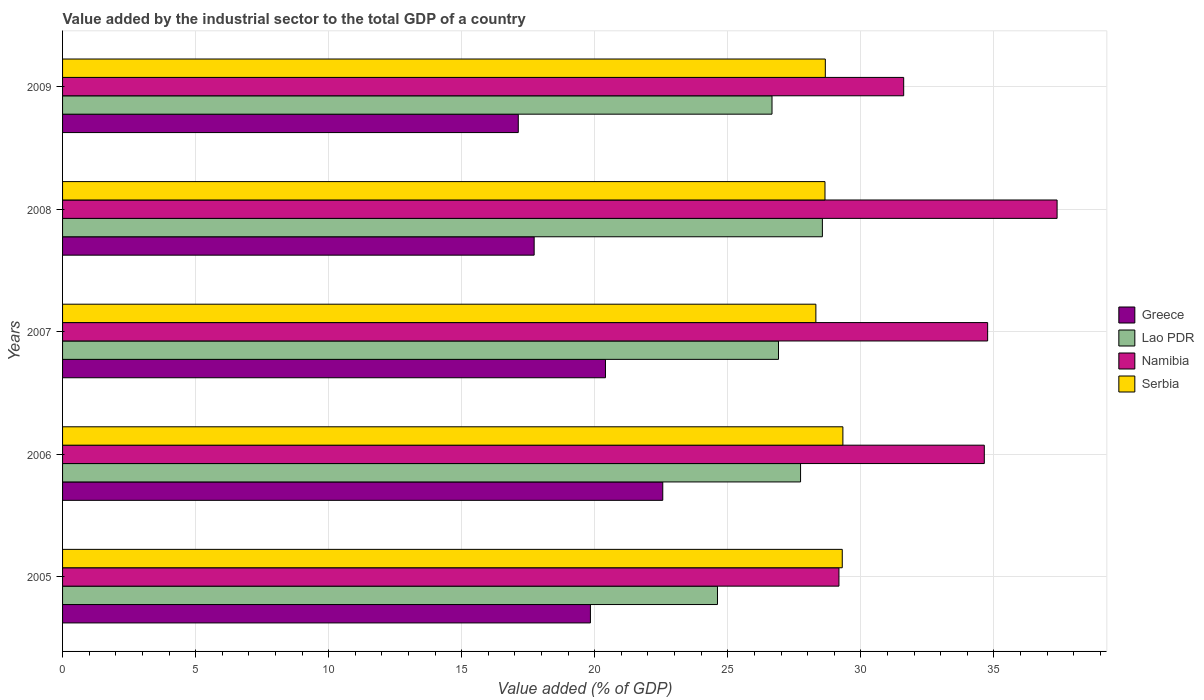How many different coloured bars are there?
Provide a short and direct response. 4. Are the number of bars on each tick of the Y-axis equal?
Keep it short and to the point. Yes. What is the value added by the industrial sector to the total GDP in Serbia in 2009?
Your answer should be compact. 28.67. Across all years, what is the maximum value added by the industrial sector to the total GDP in Greece?
Keep it short and to the point. 22.56. Across all years, what is the minimum value added by the industrial sector to the total GDP in Lao PDR?
Make the answer very short. 24.61. In which year was the value added by the industrial sector to the total GDP in Lao PDR minimum?
Make the answer very short. 2005. What is the total value added by the industrial sector to the total GDP in Lao PDR in the graph?
Your response must be concise. 134.47. What is the difference between the value added by the industrial sector to the total GDP in Namibia in 2006 and that in 2008?
Give a very brief answer. -2.74. What is the difference between the value added by the industrial sector to the total GDP in Serbia in 2005 and the value added by the industrial sector to the total GDP in Greece in 2009?
Your answer should be compact. 12.18. What is the average value added by the industrial sector to the total GDP in Greece per year?
Your response must be concise. 19.53. In the year 2005, what is the difference between the value added by the industrial sector to the total GDP in Greece and value added by the industrial sector to the total GDP in Namibia?
Your response must be concise. -9.34. What is the ratio of the value added by the industrial sector to the total GDP in Serbia in 2005 to that in 2009?
Make the answer very short. 1.02. Is the value added by the industrial sector to the total GDP in Serbia in 2006 less than that in 2007?
Your response must be concise. No. What is the difference between the highest and the second highest value added by the industrial sector to the total GDP in Namibia?
Your answer should be very brief. 2.61. What is the difference between the highest and the lowest value added by the industrial sector to the total GDP in Lao PDR?
Provide a succinct answer. 3.94. In how many years, is the value added by the industrial sector to the total GDP in Serbia greater than the average value added by the industrial sector to the total GDP in Serbia taken over all years?
Your answer should be compact. 2. Is the sum of the value added by the industrial sector to the total GDP in Greece in 2005 and 2006 greater than the maximum value added by the industrial sector to the total GDP in Serbia across all years?
Your answer should be very brief. Yes. Is it the case that in every year, the sum of the value added by the industrial sector to the total GDP in Greece and value added by the industrial sector to the total GDP in Namibia is greater than the sum of value added by the industrial sector to the total GDP in Lao PDR and value added by the industrial sector to the total GDP in Serbia?
Make the answer very short. No. What does the 4th bar from the top in 2005 represents?
Keep it short and to the point. Greece. What does the 3rd bar from the bottom in 2009 represents?
Your answer should be very brief. Namibia. Is it the case that in every year, the sum of the value added by the industrial sector to the total GDP in Namibia and value added by the industrial sector to the total GDP in Greece is greater than the value added by the industrial sector to the total GDP in Serbia?
Give a very brief answer. Yes. How many bars are there?
Your answer should be very brief. 20. How many years are there in the graph?
Provide a succinct answer. 5. Does the graph contain any zero values?
Ensure brevity in your answer.  No. How many legend labels are there?
Make the answer very short. 4. How are the legend labels stacked?
Give a very brief answer. Vertical. What is the title of the graph?
Offer a terse response. Value added by the industrial sector to the total GDP of a country. What is the label or title of the X-axis?
Offer a very short reply. Value added (% of GDP). What is the Value added (% of GDP) of Greece in 2005?
Make the answer very short. 19.84. What is the Value added (% of GDP) in Lao PDR in 2005?
Offer a very short reply. 24.61. What is the Value added (% of GDP) in Namibia in 2005?
Give a very brief answer. 29.18. What is the Value added (% of GDP) in Serbia in 2005?
Make the answer very short. 29.3. What is the Value added (% of GDP) in Greece in 2006?
Provide a short and direct response. 22.56. What is the Value added (% of GDP) of Lao PDR in 2006?
Make the answer very short. 27.73. What is the Value added (% of GDP) of Namibia in 2006?
Offer a terse response. 34.64. What is the Value added (% of GDP) in Serbia in 2006?
Your response must be concise. 29.33. What is the Value added (% of GDP) of Greece in 2007?
Make the answer very short. 20.4. What is the Value added (% of GDP) of Lao PDR in 2007?
Ensure brevity in your answer.  26.91. What is the Value added (% of GDP) of Namibia in 2007?
Provide a short and direct response. 34.77. What is the Value added (% of GDP) in Serbia in 2007?
Ensure brevity in your answer.  28.31. What is the Value added (% of GDP) in Greece in 2008?
Ensure brevity in your answer.  17.72. What is the Value added (% of GDP) in Lao PDR in 2008?
Offer a very short reply. 28.56. What is the Value added (% of GDP) in Namibia in 2008?
Offer a very short reply. 37.38. What is the Value added (% of GDP) in Serbia in 2008?
Ensure brevity in your answer.  28.65. What is the Value added (% of GDP) of Greece in 2009?
Offer a very short reply. 17.13. What is the Value added (% of GDP) of Lao PDR in 2009?
Make the answer very short. 26.66. What is the Value added (% of GDP) of Namibia in 2009?
Provide a short and direct response. 31.61. What is the Value added (% of GDP) in Serbia in 2009?
Keep it short and to the point. 28.67. Across all years, what is the maximum Value added (% of GDP) in Greece?
Ensure brevity in your answer.  22.56. Across all years, what is the maximum Value added (% of GDP) in Lao PDR?
Make the answer very short. 28.56. Across all years, what is the maximum Value added (% of GDP) in Namibia?
Give a very brief answer. 37.38. Across all years, what is the maximum Value added (% of GDP) in Serbia?
Give a very brief answer. 29.33. Across all years, what is the minimum Value added (% of GDP) of Greece?
Your response must be concise. 17.13. Across all years, what is the minimum Value added (% of GDP) in Lao PDR?
Your response must be concise. 24.61. Across all years, what is the minimum Value added (% of GDP) in Namibia?
Your answer should be very brief. 29.18. Across all years, what is the minimum Value added (% of GDP) in Serbia?
Ensure brevity in your answer.  28.31. What is the total Value added (% of GDP) of Greece in the graph?
Make the answer very short. 97.65. What is the total Value added (% of GDP) in Lao PDR in the graph?
Provide a succinct answer. 134.47. What is the total Value added (% of GDP) of Namibia in the graph?
Offer a terse response. 167.57. What is the total Value added (% of GDP) of Serbia in the graph?
Make the answer very short. 144.26. What is the difference between the Value added (% of GDP) of Greece in 2005 and that in 2006?
Ensure brevity in your answer.  -2.72. What is the difference between the Value added (% of GDP) in Lao PDR in 2005 and that in 2006?
Offer a very short reply. -3.12. What is the difference between the Value added (% of GDP) in Namibia in 2005 and that in 2006?
Keep it short and to the point. -5.46. What is the difference between the Value added (% of GDP) in Serbia in 2005 and that in 2006?
Provide a succinct answer. -0.02. What is the difference between the Value added (% of GDP) in Greece in 2005 and that in 2007?
Keep it short and to the point. -0.57. What is the difference between the Value added (% of GDP) of Lao PDR in 2005 and that in 2007?
Your response must be concise. -2.29. What is the difference between the Value added (% of GDP) of Namibia in 2005 and that in 2007?
Your response must be concise. -5.59. What is the difference between the Value added (% of GDP) of Serbia in 2005 and that in 2007?
Your answer should be compact. 0.99. What is the difference between the Value added (% of GDP) in Greece in 2005 and that in 2008?
Your answer should be very brief. 2.11. What is the difference between the Value added (% of GDP) in Lao PDR in 2005 and that in 2008?
Give a very brief answer. -3.94. What is the difference between the Value added (% of GDP) in Namibia in 2005 and that in 2008?
Keep it short and to the point. -8.2. What is the difference between the Value added (% of GDP) of Serbia in 2005 and that in 2008?
Offer a terse response. 0.65. What is the difference between the Value added (% of GDP) in Greece in 2005 and that in 2009?
Your answer should be very brief. 2.71. What is the difference between the Value added (% of GDP) in Lao PDR in 2005 and that in 2009?
Provide a succinct answer. -2.05. What is the difference between the Value added (% of GDP) of Namibia in 2005 and that in 2009?
Provide a short and direct response. -2.43. What is the difference between the Value added (% of GDP) in Serbia in 2005 and that in 2009?
Your answer should be compact. 0.64. What is the difference between the Value added (% of GDP) of Greece in 2006 and that in 2007?
Provide a short and direct response. 2.15. What is the difference between the Value added (% of GDP) in Lao PDR in 2006 and that in 2007?
Ensure brevity in your answer.  0.83. What is the difference between the Value added (% of GDP) in Namibia in 2006 and that in 2007?
Ensure brevity in your answer.  -0.13. What is the difference between the Value added (% of GDP) of Serbia in 2006 and that in 2007?
Offer a very short reply. 1.02. What is the difference between the Value added (% of GDP) in Greece in 2006 and that in 2008?
Your response must be concise. 4.83. What is the difference between the Value added (% of GDP) in Lao PDR in 2006 and that in 2008?
Offer a very short reply. -0.82. What is the difference between the Value added (% of GDP) of Namibia in 2006 and that in 2008?
Provide a short and direct response. -2.74. What is the difference between the Value added (% of GDP) of Serbia in 2006 and that in 2008?
Your response must be concise. 0.67. What is the difference between the Value added (% of GDP) in Greece in 2006 and that in 2009?
Provide a succinct answer. 5.43. What is the difference between the Value added (% of GDP) of Lao PDR in 2006 and that in 2009?
Make the answer very short. 1.07. What is the difference between the Value added (% of GDP) in Namibia in 2006 and that in 2009?
Make the answer very short. 3.03. What is the difference between the Value added (% of GDP) of Serbia in 2006 and that in 2009?
Keep it short and to the point. 0.66. What is the difference between the Value added (% of GDP) in Greece in 2007 and that in 2008?
Your response must be concise. 2.68. What is the difference between the Value added (% of GDP) of Lao PDR in 2007 and that in 2008?
Your answer should be very brief. -1.65. What is the difference between the Value added (% of GDP) of Namibia in 2007 and that in 2008?
Ensure brevity in your answer.  -2.61. What is the difference between the Value added (% of GDP) of Serbia in 2007 and that in 2008?
Give a very brief answer. -0.34. What is the difference between the Value added (% of GDP) of Greece in 2007 and that in 2009?
Provide a succinct answer. 3.28. What is the difference between the Value added (% of GDP) in Lao PDR in 2007 and that in 2009?
Your answer should be very brief. 0.24. What is the difference between the Value added (% of GDP) of Namibia in 2007 and that in 2009?
Make the answer very short. 3.15. What is the difference between the Value added (% of GDP) in Serbia in 2007 and that in 2009?
Your answer should be very brief. -0.36. What is the difference between the Value added (% of GDP) of Greece in 2008 and that in 2009?
Offer a very short reply. 0.6. What is the difference between the Value added (% of GDP) in Lao PDR in 2008 and that in 2009?
Provide a short and direct response. 1.89. What is the difference between the Value added (% of GDP) in Namibia in 2008 and that in 2009?
Provide a succinct answer. 5.77. What is the difference between the Value added (% of GDP) in Serbia in 2008 and that in 2009?
Provide a succinct answer. -0.01. What is the difference between the Value added (% of GDP) in Greece in 2005 and the Value added (% of GDP) in Lao PDR in 2006?
Provide a succinct answer. -7.9. What is the difference between the Value added (% of GDP) in Greece in 2005 and the Value added (% of GDP) in Namibia in 2006?
Provide a short and direct response. -14.8. What is the difference between the Value added (% of GDP) of Greece in 2005 and the Value added (% of GDP) of Serbia in 2006?
Your answer should be very brief. -9.49. What is the difference between the Value added (% of GDP) in Lao PDR in 2005 and the Value added (% of GDP) in Namibia in 2006?
Ensure brevity in your answer.  -10.03. What is the difference between the Value added (% of GDP) of Lao PDR in 2005 and the Value added (% of GDP) of Serbia in 2006?
Ensure brevity in your answer.  -4.71. What is the difference between the Value added (% of GDP) of Namibia in 2005 and the Value added (% of GDP) of Serbia in 2006?
Your response must be concise. -0.15. What is the difference between the Value added (% of GDP) in Greece in 2005 and the Value added (% of GDP) in Lao PDR in 2007?
Provide a short and direct response. -7.07. What is the difference between the Value added (% of GDP) in Greece in 2005 and the Value added (% of GDP) in Namibia in 2007?
Provide a short and direct response. -14.93. What is the difference between the Value added (% of GDP) of Greece in 2005 and the Value added (% of GDP) of Serbia in 2007?
Offer a terse response. -8.47. What is the difference between the Value added (% of GDP) in Lao PDR in 2005 and the Value added (% of GDP) in Namibia in 2007?
Provide a succinct answer. -10.15. What is the difference between the Value added (% of GDP) of Lao PDR in 2005 and the Value added (% of GDP) of Serbia in 2007?
Your answer should be very brief. -3.7. What is the difference between the Value added (% of GDP) in Namibia in 2005 and the Value added (% of GDP) in Serbia in 2007?
Provide a short and direct response. 0.87. What is the difference between the Value added (% of GDP) of Greece in 2005 and the Value added (% of GDP) of Lao PDR in 2008?
Your answer should be very brief. -8.72. What is the difference between the Value added (% of GDP) in Greece in 2005 and the Value added (% of GDP) in Namibia in 2008?
Your response must be concise. -17.54. What is the difference between the Value added (% of GDP) of Greece in 2005 and the Value added (% of GDP) of Serbia in 2008?
Ensure brevity in your answer.  -8.81. What is the difference between the Value added (% of GDP) of Lao PDR in 2005 and the Value added (% of GDP) of Namibia in 2008?
Keep it short and to the point. -12.76. What is the difference between the Value added (% of GDP) in Lao PDR in 2005 and the Value added (% of GDP) in Serbia in 2008?
Offer a very short reply. -4.04. What is the difference between the Value added (% of GDP) in Namibia in 2005 and the Value added (% of GDP) in Serbia in 2008?
Provide a succinct answer. 0.53. What is the difference between the Value added (% of GDP) in Greece in 2005 and the Value added (% of GDP) in Lao PDR in 2009?
Give a very brief answer. -6.82. What is the difference between the Value added (% of GDP) of Greece in 2005 and the Value added (% of GDP) of Namibia in 2009?
Offer a very short reply. -11.77. What is the difference between the Value added (% of GDP) of Greece in 2005 and the Value added (% of GDP) of Serbia in 2009?
Provide a short and direct response. -8.83. What is the difference between the Value added (% of GDP) of Lao PDR in 2005 and the Value added (% of GDP) of Namibia in 2009?
Your answer should be very brief. -7. What is the difference between the Value added (% of GDP) in Lao PDR in 2005 and the Value added (% of GDP) in Serbia in 2009?
Keep it short and to the point. -4.05. What is the difference between the Value added (% of GDP) in Namibia in 2005 and the Value added (% of GDP) in Serbia in 2009?
Your answer should be compact. 0.51. What is the difference between the Value added (% of GDP) of Greece in 2006 and the Value added (% of GDP) of Lao PDR in 2007?
Your answer should be compact. -4.35. What is the difference between the Value added (% of GDP) in Greece in 2006 and the Value added (% of GDP) in Namibia in 2007?
Provide a short and direct response. -12.21. What is the difference between the Value added (% of GDP) of Greece in 2006 and the Value added (% of GDP) of Serbia in 2007?
Keep it short and to the point. -5.75. What is the difference between the Value added (% of GDP) in Lao PDR in 2006 and the Value added (% of GDP) in Namibia in 2007?
Your answer should be compact. -7.03. What is the difference between the Value added (% of GDP) of Lao PDR in 2006 and the Value added (% of GDP) of Serbia in 2007?
Your answer should be compact. -0.58. What is the difference between the Value added (% of GDP) of Namibia in 2006 and the Value added (% of GDP) of Serbia in 2007?
Give a very brief answer. 6.33. What is the difference between the Value added (% of GDP) of Greece in 2006 and the Value added (% of GDP) of Lao PDR in 2008?
Your answer should be compact. -6. What is the difference between the Value added (% of GDP) in Greece in 2006 and the Value added (% of GDP) in Namibia in 2008?
Your response must be concise. -14.82. What is the difference between the Value added (% of GDP) in Greece in 2006 and the Value added (% of GDP) in Serbia in 2008?
Your answer should be compact. -6.1. What is the difference between the Value added (% of GDP) of Lao PDR in 2006 and the Value added (% of GDP) of Namibia in 2008?
Ensure brevity in your answer.  -9.64. What is the difference between the Value added (% of GDP) of Lao PDR in 2006 and the Value added (% of GDP) of Serbia in 2008?
Keep it short and to the point. -0.92. What is the difference between the Value added (% of GDP) in Namibia in 2006 and the Value added (% of GDP) in Serbia in 2008?
Make the answer very short. 5.99. What is the difference between the Value added (% of GDP) in Greece in 2006 and the Value added (% of GDP) in Lao PDR in 2009?
Keep it short and to the point. -4.11. What is the difference between the Value added (% of GDP) in Greece in 2006 and the Value added (% of GDP) in Namibia in 2009?
Provide a succinct answer. -9.05. What is the difference between the Value added (% of GDP) in Greece in 2006 and the Value added (% of GDP) in Serbia in 2009?
Offer a very short reply. -6.11. What is the difference between the Value added (% of GDP) in Lao PDR in 2006 and the Value added (% of GDP) in Namibia in 2009?
Ensure brevity in your answer.  -3.88. What is the difference between the Value added (% of GDP) of Lao PDR in 2006 and the Value added (% of GDP) of Serbia in 2009?
Your response must be concise. -0.93. What is the difference between the Value added (% of GDP) of Namibia in 2006 and the Value added (% of GDP) of Serbia in 2009?
Your answer should be compact. 5.97. What is the difference between the Value added (% of GDP) of Greece in 2007 and the Value added (% of GDP) of Lao PDR in 2008?
Provide a succinct answer. -8.15. What is the difference between the Value added (% of GDP) of Greece in 2007 and the Value added (% of GDP) of Namibia in 2008?
Give a very brief answer. -16.97. What is the difference between the Value added (% of GDP) in Greece in 2007 and the Value added (% of GDP) in Serbia in 2008?
Provide a succinct answer. -8.25. What is the difference between the Value added (% of GDP) in Lao PDR in 2007 and the Value added (% of GDP) in Namibia in 2008?
Provide a short and direct response. -10.47. What is the difference between the Value added (% of GDP) in Lao PDR in 2007 and the Value added (% of GDP) in Serbia in 2008?
Ensure brevity in your answer.  -1.75. What is the difference between the Value added (% of GDP) of Namibia in 2007 and the Value added (% of GDP) of Serbia in 2008?
Your answer should be compact. 6.11. What is the difference between the Value added (% of GDP) of Greece in 2007 and the Value added (% of GDP) of Lao PDR in 2009?
Make the answer very short. -6.26. What is the difference between the Value added (% of GDP) in Greece in 2007 and the Value added (% of GDP) in Namibia in 2009?
Ensure brevity in your answer.  -11.21. What is the difference between the Value added (% of GDP) in Greece in 2007 and the Value added (% of GDP) in Serbia in 2009?
Offer a terse response. -8.26. What is the difference between the Value added (% of GDP) in Lao PDR in 2007 and the Value added (% of GDP) in Namibia in 2009?
Offer a very short reply. -4.71. What is the difference between the Value added (% of GDP) of Lao PDR in 2007 and the Value added (% of GDP) of Serbia in 2009?
Keep it short and to the point. -1.76. What is the difference between the Value added (% of GDP) in Namibia in 2007 and the Value added (% of GDP) in Serbia in 2009?
Your answer should be compact. 6.1. What is the difference between the Value added (% of GDP) in Greece in 2008 and the Value added (% of GDP) in Lao PDR in 2009?
Provide a succinct answer. -8.94. What is the difference between the Value added (% of GDP) in Greece in 2008 and the Value added (% of GDP) in Namibia in 2009?
Your response must be concise. -13.89. What is the difference between the Value added (% of GDP) in Greece in 2008 and the Value added (% of GDP) in Serbia in 2009?
Your response must be concise. -10.94. What is the difference between the Value added (% of GDP) of Lao PDR in 2008 and the Value added (% of GDP) of Namibia in 2009?
Ensure brevity in your answer.  -3.06. What is the difference between the Value added (% of GDP) of Lao PDR in 2008 and the Value added (% of GDP) of Serbia in 2009?
Make the answer very short. -0.11. What is the difference between the Value added (% of GDP) of Namibia in 2008 and the Value added (% of GDP) of Serbia in 2009?
Make the answer very short. 8.71. What is the average Value added (% of GDP) in Greece per year?
Offer a terse response. 19.53. What is the average Value added (% of GDP) in Lao PDR per year?
Keep it short and to the point. 26.89. What is the average Value added (% of GDP) in Namibia per year?
Your answer should be compact. 33.51. What is the average Value added (% of GDP) in Serbia per year?
Offer a terse response. 28.85. In the year 2005, what is the difference between the Value added (% of GDP) in Greece and Value added (% of GDP) in Lao PDR?
Ensure brevity in your answer.  -4.77. In the year 2005, what is the difference between the Value added (% of GDP) in Greece and Value added (% of GDP) in Namibia?
Offer a terse response. -9.34. In the year 2005, what is the difference between the Value added (% of GDP) of Greece and Value added (% of GDP) of Serbia?
Ensure brevity in your answer.  -9.46. In the year 2005, what is the difference between the Value added (% of GDP) in Lao PDR and Value added (% of GDP) in Namibia?
Provide a succinct answer. -4.57. In the year 2005, what is the difference between the Value added (% of GDP) of Lao PDR and Value added (% of GDP) of Serbia?
Your response must be concise. -4.69. In the year 2005, what is the difference between the Value added (% of GDP) of Namibia and Value added (% of GDP) of Serbia?
Make the answer very short. -0.12. In the year 2006, what is the difference between the Value added (% of GDP) in Greece and Value added (% of GDP) in Lao PDR?
Offer a very short reply. -5.18. In the year 2006, what is the difference between the Value added (% of GDP) of Greece and Value added (% of GDP) of Namibia?
Offer a terse response. -12.08. In the year 2006, what is the difference between the Value added (% of GDP) in Greece and Value added (% of GDP) in Serbia?
Your response must be concise. -6.77. In the year 2006, what is the difference between the Value added (% of GDP) of Lao PDR and Value added (% of GDP) of Namibia?
Make the answer very short. -6.91. In the year 2006, what is the difference between the Value added (% of GDP) of Lao PDR and Value added (% of GDP) of Serbia?
Provide a short and direct response. -1.59. In the year 2006, what is the difference between the Value added (% of GDP) in Namibia and Value added (% of GDP) in Serbia?
Your answer should be compact. 5.31. In the year 2007, what is the difference between the Value added (% of GDP) in Greece and Value added (% of GDP) in Lao PDR?
Provide a succinct answer. -6.5. In the year 2007, what is the difference between the Value added (% of GDP) of Greece and Value added (% of GDP) of Namibia?
Make the answer very short. -14.36. In the year 2007, what is the difference between the Value added (% of GDP) of Greece and Value added (% of GDP) of Serbia?
Your answer should be very brief. -7.91. In the year 2007, what is the difference between the Value added (% of GDP) of Lao PDR and Value added (% of GDP) of Namibia?
Provide a succinct answer. -7.86. In the year 2007, what is the difference between the Value added (% of GDP) of Lao PDR and Value added (% of GDP) of Serbia?
Provide a succinct answer. -1.4. In the year 2007, what is the difference between the Value added (% of GDP) in Namibia and Value added (% of GDP) in Serbia?
Keep it short and to the point. 6.46. In the year 2008, what is the difference between the Value added (% of GDP) of Greece and Value added (% of GDP) of Lao PDR?
Your answer should be very brief. -10.83. In the year 2008, what is the difference between the Value added (% of GDP) of Greece and Value added (% of GDP) of Namibia?
Your answer should be compact. -19.65. In the year 2008, what is the difference between the Value added (% of GDP) of Greece and Value added (% of GDP) of Serbia?
Offer a very short reply. -10.93. In the year 2008, what is the difference between the Value added (% of GDP) of Lao PDR and Value added (% of GDP) of Namibia?
Ensure brevity in your answer.  -8.82. In the year 2008, what is the difference between the Value added (% of GDP) of Lao PDR and Value added (% of GDP) of Serbia?
Keep it short and to the point. -0.1. In the year 2008, what is the difference between the Value added (% of GDP) of Namibia and Value added (% of GDP) of Serbia?
Give a very brief answer. 8.72. In the year 2009, what is the difference between the Value added (% of GDP) of Greece and Value added (% of GDP) of Lao PDR?
Keep it short and to the point. -9.54. In the year 2009, what is the difference between the Value added (% of GDP) in Greece and Value added (% of GDP) in Namibia?
Your answer should be very brief. -14.48. In the year 2009, what is the difference between the Value added (% of GDP) in Greece and Value added (% of GDP) in Serbia?
Your answer should be very brief. -11.54. In the year 2009, what is the difference between the Value added (% of GDP) in Lao PDR and Value added (% of GDP) in Namibia?
Make the answer very short. -4.95. In the year 2009, what is the difference between the Value added (% of GDP) of Lao PDR and Value added (% of GDP) of Serbia?
Provide a succinct answer. -2. In the year 2009, what is the difference between the Value added (% of GDP) in Namibia and Value added (% of GDP) in Serbia?
Give a very brief answer. 2.95. What is the ratio of the Value added (% of GDP) in Greece in 2005 to that in 2006?
Provide a short and direct response. 0.88. What is the ratio of the Value added (% of GDP) of Lao PDR in 2005 to that in 2006?
Offer a very short reply. 0.89. What is the ratio of the Value added (% of GDP) in Namibia in 2005 to that in 2006?
Your response must be concise. 0.84. What is the ratio of the Value added (% of GDP) of Serbia in 2005 to that in 2006?
Your response must be concise. 1. What is the ratio of the Value added (% of GDP) of Greece in 2005 to that in 2007?
Keep it short and to the point. 0.97. What is the ratio of the Value added (% of GDP) of Lao PDR in 2005 to that in 2007?
Your answer should be very brief. 0.91. What is the ratio of the Value added (% of GDP) in Namibia in 2005 to that in 2007?
Keep it short and to the point. 0.84. What is the ratio of the Value added (% of GDP) of Serbia in 2005 to that in 2007?
Make the answer very short. 1.03. What is the ratio of the Value added (% of GDP) in Greece in 2005 to that in 2008?
Your response must be concise. 1.12. What is the ratio of the Value added (% of GDP) of Lao PDR in 2005 to that in 2008?
Provide a succinct answer. 0.86. What is the ratio of the Value added (% of GDP) of Namibia in 2005 to that in 2008?
Keep it short and to the point. 0.78. What is the ratio of the Value added (% of GDP) of Serbia in 2005 to that in 2008?
Your answer should be very brief. 1.02. What is the ratio of the Value added (% of GDP) in Greece in 2005 to that in 2009?
Provide a short and direct response. 1.16. What is the ratio of the Value added (% of GDP) in Lao PDR in 2005 to that in 2009?
Your response must be concise. 0.92. What is the ratio of the Value added (% of GDP) in Namibia in 2005 to that in 2009?
Your answer should be compact. 0.92. What is the ratio of the Value added (% of GDP) of Serbia in 2005 to that in 2009?
Provide a succinct answer. 1.02. What is the ratio of the Value added (% of GDP) of Greece in 2006 to that in 2007?
Provide a succinct answer. 1.11. What is the ratio of the Value added (% of GDP) in Lao PDR in 2006 to that in 2007?
Provide a succinct answer. 1.03. What is the ratio of the Value added (% of GDP) of Serbia in 2006 to that in 2007?
Provide a succinct answer. 1.04. What is the ratio of the Value added (% of GDP) in Greece in 2006 to that in 2008?
Make the answer very short. 1.27. What is the ratio of the Value added (% of GDP) in Lao PDR in 2006 to that in 2008?
Your answer should be very brief. 0.97. What is the ratio of the Value added (% of GDP) in Namibia in 2006 to that in 2008?
Make the answer very short. 0.93. What is the ratio of the Value added (% of GDP) in Serbia in 2006 to that in 2008?
Your answer should be compact. 1.02. What is the ratio of the Value added (% of GDP) of Greece in 2006 to that in 2009?
Ensure brevity in your answer.  1.32. What is the ratio of the Value added (% of GDP) of Lao PDR in 2006 to that in 2009?
Make the answer very short. 1.04. What is the ratio of the Value added (% of GDP) of Namibia in 2006 to that in 2009?
Ensure brevity in your answer.  1.1. What is the ratio of the Value added (% of GDP) of Serbia in 2006 to that in 2009?
Provide a short and direct response. 1.02. What is the ratio of the Value added (% of GDP) of Greece in 2007 to that in 2008?
Keep it short and to the point. 1.15. What is the ratio of the Value added (% of GDP) in Lao PDR in 2007 to that in 2008?
Your response must be concise. 0.94. What is the ratio of the Value added (% of GDP) of Namibia in 2007 to that in 2008?
Your response must be concise. 0.93. What is the ratio of the Value added (% of GDP) of Greece in 2007 to that in 2009?
Make the answer very short. 1.19. What is the ratio of the Value added (% of GDP) in Lao PDR in 2007 to that in 2009?
Your answer should be compact. 1.01. What is the ratio of the Value added (% of GDP) in Namibia in 2007 to that in 2009?
Your response must be concise. 1.1. What is the ratio of the Value added (% of GDP) of Serbia in 2007 to that in 2009?
Ensure brevity in your answer.  0.99. What is the ratio of the Value added (% of GDP) in Greece in 2008 to that in 2009?
Offer a terse response. 1.03. What is the ratio of the Value added (% of GDP) in Lao PDR in 2008 to that in 2009?
Your response must be concise. 1.07. What is the ratio of the Value added (% of GDP) of Namibia in 2008 to that in 2009?
Provide a succinct answer. 1.18. What is the difference between the highest and the second highest Value added (% of GDP) of Greece?
Give a very brief answer. 2.15. What is the difference between the highest and the second highest Value added (% of GDP) in Lao PDR?
Your answer should be compact. 0.82. What is the difference between the highest and the second highest Value added (% of GDP) of Namibia?
Offer a very short reply. 2.61. What is the difference between the highest and the second highest Value added (% of GDP) in Serbia?
Provide a succinct answer. 0.02. What is the difference between the highest and the lowest Value added (% of GDP) in Greece?
Your answer should be very brief. 5.43. What is the difference between the highest and the lowest Value added (% of GDP) of Lao PDR?
Make the answer very short. 3.94. What is the difference between the highest and the lowest Value added (% of GDP) of Namibia?
Keep it short and to the point. 8.2. What is the difference between the highest and the lowest Value added (% of GDP) in Serbia?
Give a very brief answer. 1.02. 